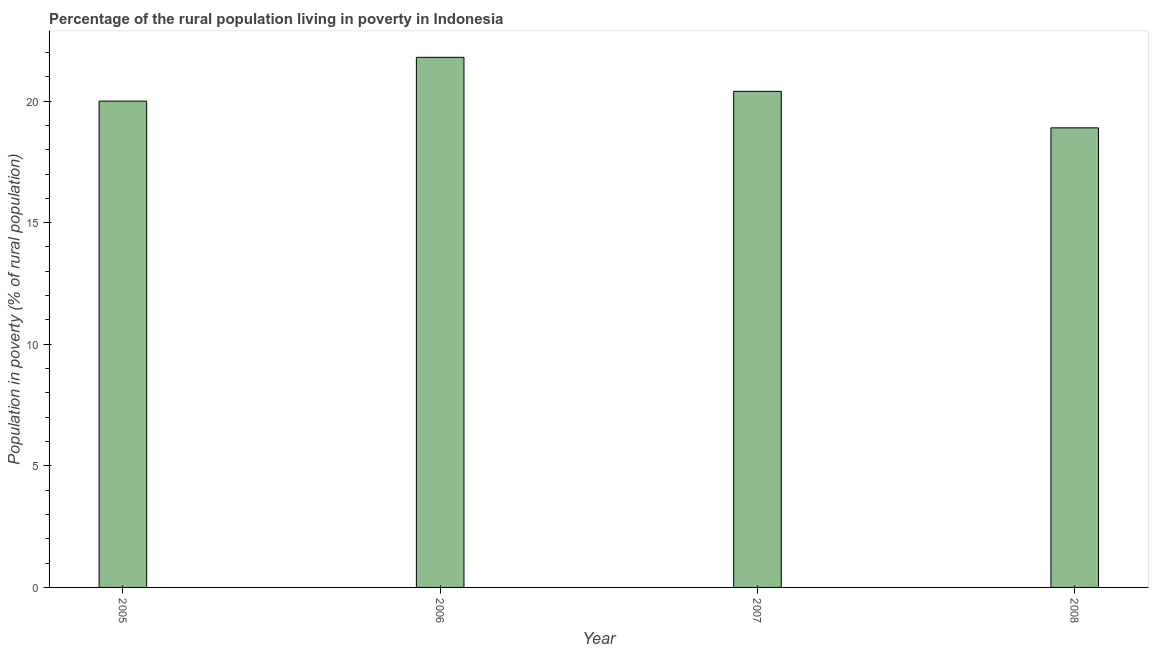Does the graph contain any zero values?
Your answer should be compact. No. Does the graph contain grids?
Your answer should be very brief. No. What is the title of the graph?
Your answer should be very brief. Percentage of the rural population living in poverty in Indonesia. What is the label or title of the Y-axis?
Provide a short and direct response. Population in poverty (% of rural population). What is the percentage of rural population living below poverty line in 2007?
Offer a very short reply. 20.4. Across all years, what is the maximum percentage of rural population living below poverty line?
Your answer should be very brief. 21.8. Across all years, what is the minimum percentage of rural population living below poverty line?
Your answer should be very brief. 18.9. In which year was the percentage of rural population living below poverty line maximum?
Offer a terse response. 2006. What is the sum of the percentage of rural population living below poverty line?
Your response must be concise. 81.1. What is the difference between the percentage of rural population living below poverty line in 2007 and 2008?
Make the answer very short. 1.5. What is the average percentage of rural population living below poverty line per year?
Your answer should be compact. 20.27. What is the median percentage of rural population living below poverty line?
Give a very brief answer. 20.2. In how many years, is the percentage of rural population living below poverty line greater than 19 %?
Give a very brief answer. 3. What is the ratio of the percentage of rural population living below poverty line in 2006 to that in 2007?
Keep it short and to the point. 1.07. Is the percentage of rural population living below poverty line in 2007 less than that in 2008?
Keep it short and to the point. No. Is the difference between the percentage of rural population living below poverty line in 2006 and 2007 greater than the difference between any two years?
Offer a terse response. No. Is the sum of the percentage of rural population living below poverty line in 2006 and 2007 greater than the maximum percentage of rural population living below poverty line across all years?
Your answer should be very brief. Yes. In how many years, is the percentage of rural population living below poverty line greater than the average percentage of rural population living below poverty line taken over all years?
Your response must be concise. 2. Are all the bars in the graph horizontal?
Make the answer very short. No. What is the Population in poverty (% of rural population) of 2005?
Provide a succinct answer. 20. What is the Population in poverty (% of rural population) of 2006?
Provide a succinct answer. 21.8. What is the Population in poverty (% of rural population) of 2007?
Keep it short and to the point. 20.4. What is the Population in poverty (% of rural population) of 2008?
Offer a very short reply. 18.9. What is the difference between the Population in poverty (% of rural population) in 2007 and 2008?
Your answer should be compact. 1.5. What is the ratio of the Population in poverty (% of rural population) in 2005 to that in 2006?
Make the answer very short. 0.92. What is the ratio of the Population in poverty (% of rural population) in 2005 to that in 2008?
Your answer should be compact. 1.06. What is the ratio of the Population in poverty (% of rural population) in 2006 to that in 2007?
Provide a succinct answer. 1.07. What is the ratio of the Population in poverty (% of rural population) in 2006 to that in 2008?
Your answer should be very brief. 1.15. What is the ratio of the Population in poverty (% of rural population) in 2007 to that in 2008?
Make the answer very short. 1.08. 